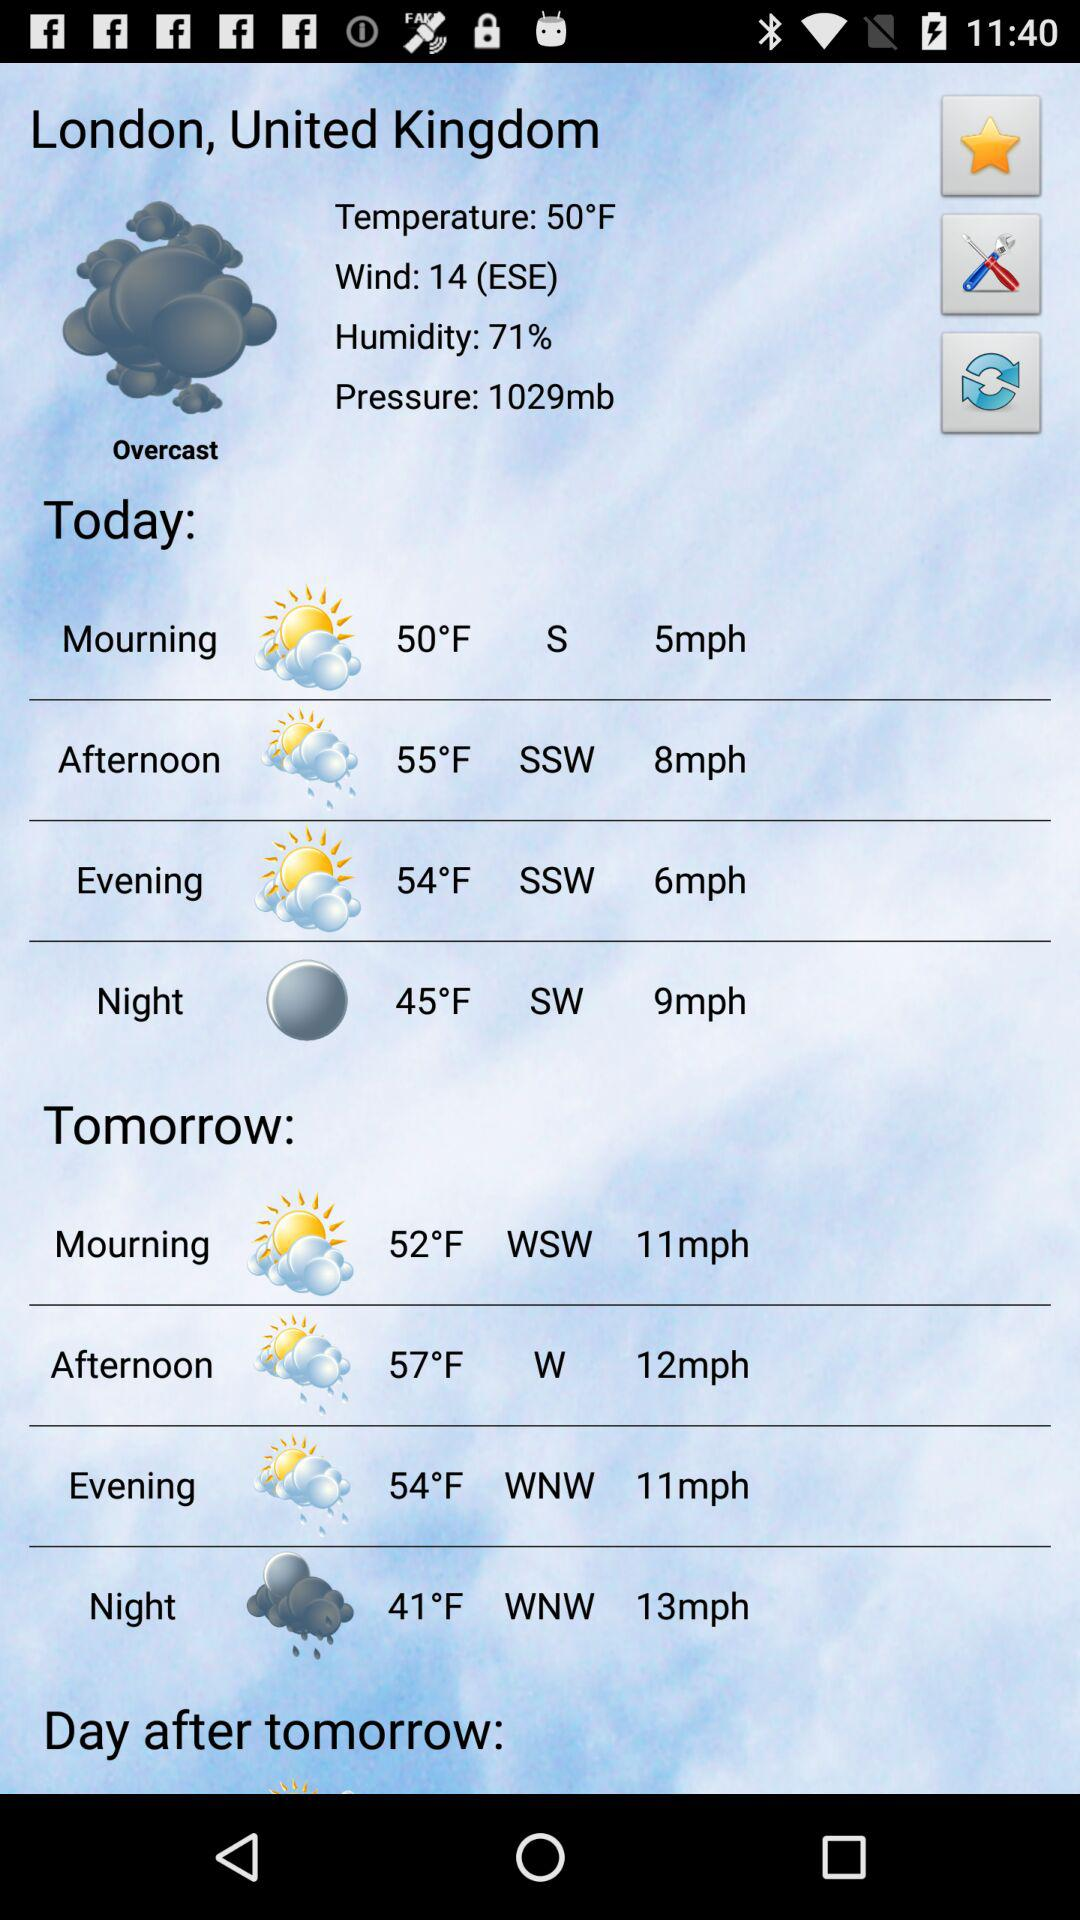What is the humidity percentage today in London? The humidity percentage today in London is 70. 